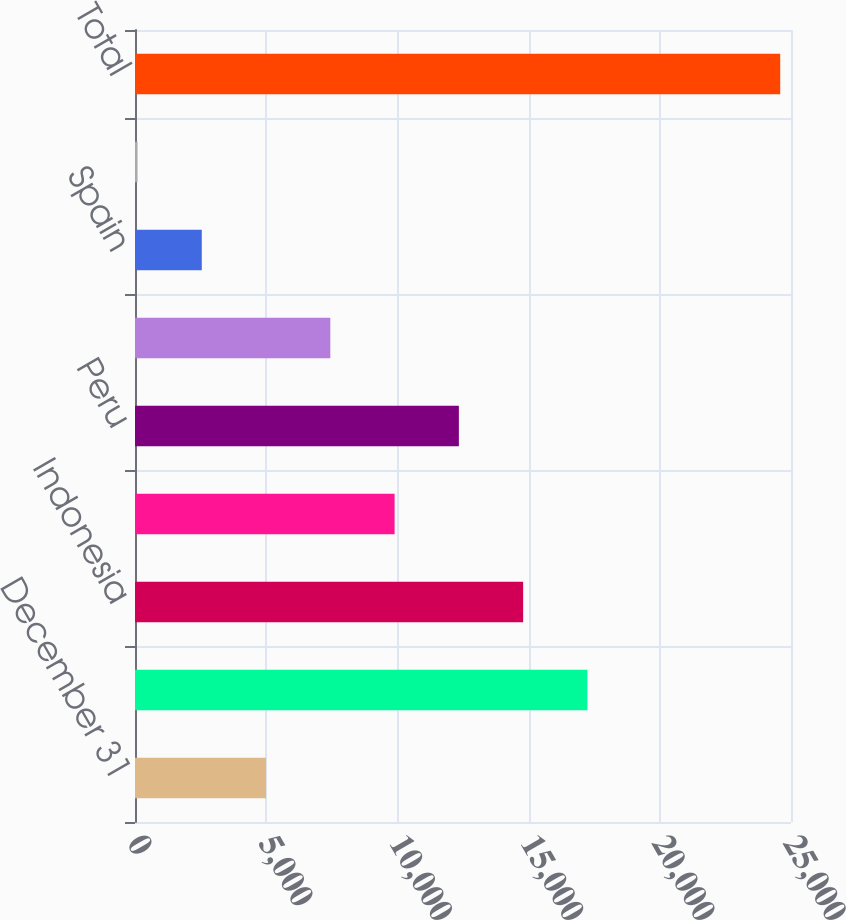Convert chart. <chart><loc_0><loc_0><loc_500><loc_500><bar_chart><fcel>December 31<fcel>United States<fcel>Indonesia<fcel>Democratic Republic of Congo<fcel>Peru<fcel>Chile<fcel>Spain<fcel>Other<fcel>Total<nl><fcel>4994.6<fcel>17241.1<fcel>14791.8<fcel>9893.2<fcel>12342.5<fcel>7443.9<fcel>2545.3<fcel>96<fcel>24589<nl></chart> 